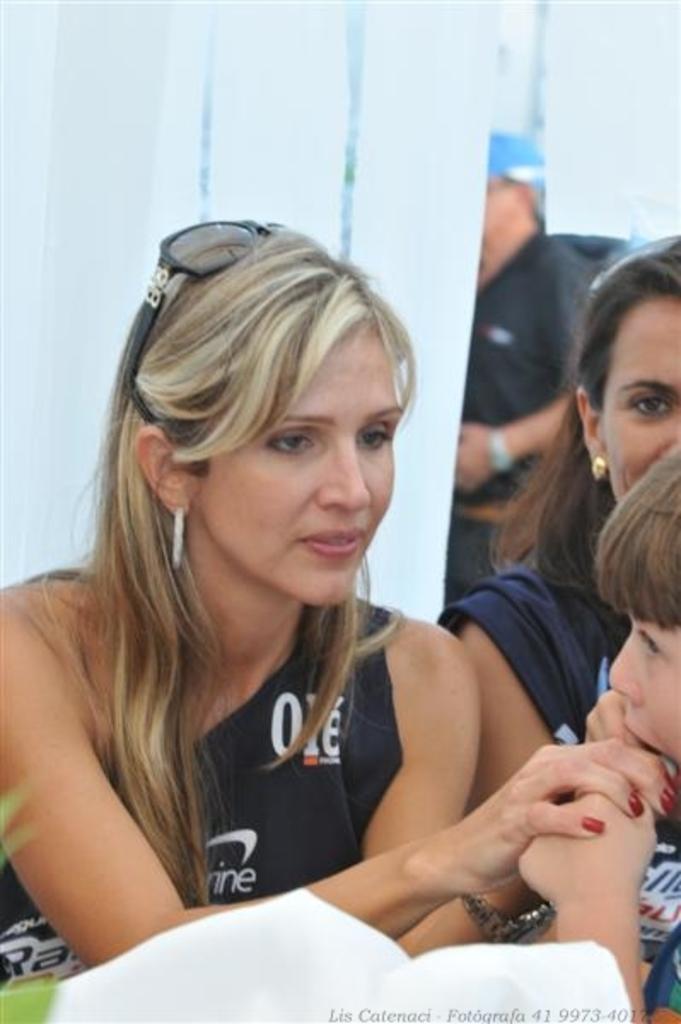Can you describe this image briefly? In this image we can see people and white objects. At the bottom of the image there is a watermark. 